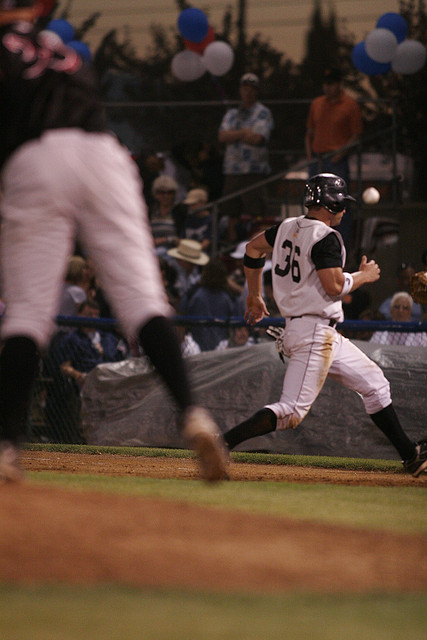Identify the text displayed in this image. 36 